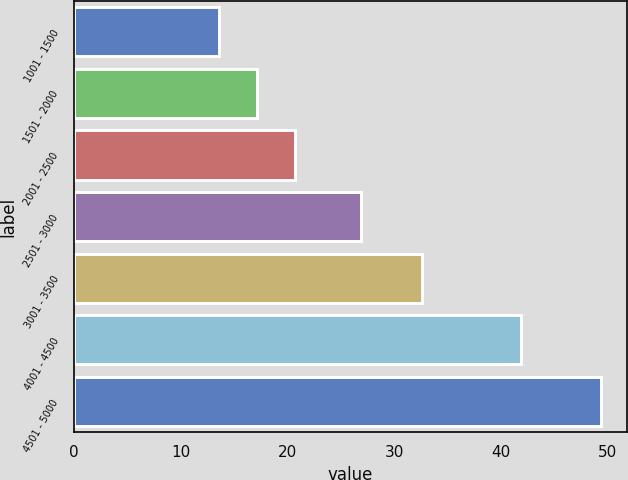<chart> <loc_0><loc_0><loc_500><loc_500><bar_chart><fcel>1001 - 1500<fcel>1501 - 2000<fcel>2001 - 2500<fcel>2501 - 3000<fcel>3001 - 3500<fcel>4001 - 4500<fcel>4501 - 5000<nl><fcel>13.58<fcel>17.16<fcel>20.74<fcel>26.91<fcel>32.65<fcel>41.88<fcel>49.36<nl></chart> 